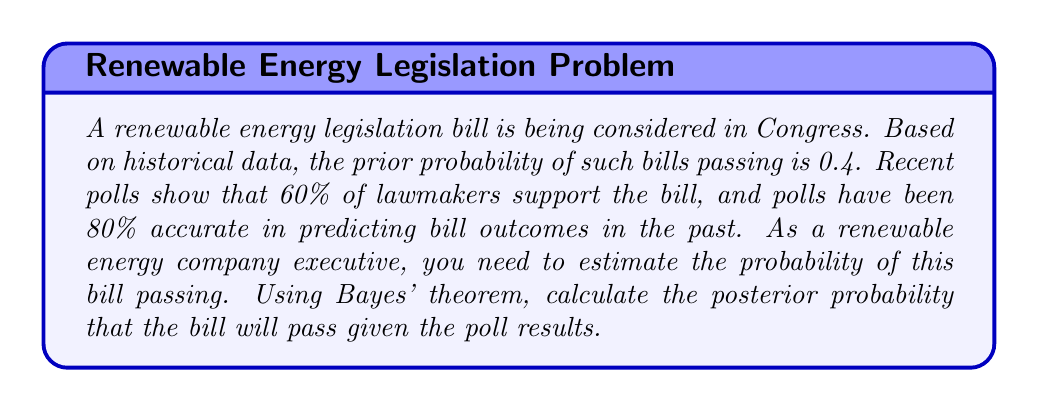Solve this math problem. Let's approach this step-by-step using Bayes' theorem:

1) Define our events:
   A: The bill passes
   B: The poll predicts the bill will pass

2) Given information:
   P(A) = 0.4 (prior probability of the bill passing)
   P(B|A) = 0.8 (probability of a correct poll prediction given the bill passes)
   P(B|not A) = 0.2 (probability of an incorrect poll prediction given the bill doesn't pass)
   P(B) = 0.6 (60% of lawmakers support the bill)

3) Bayes' theorem states:

   $$P(A|B) = \frac{P(B|A) \cdot P(A)}{P(B)}$$

4) We need to calculate P(B) using the law of total probability:

   $$P(B) = P(B|A) \cdot P(A) + P(B|not A) \cdot P(not A)$$
   $$P(B) = 0.8 \cdot 0.4 + 0.2 \cdot 0.6 = 0.32 + 0.12 = 0.44$$

5) Now we can apply Bayes' theorem:

   $$P(A|B) = \frac{0.8 \cdot 0.4}{0.44} = \frac{0.32}{0.44} \approx 0.7273$$

6) Convert to a percentage:
   0.7273 * 100 ≈ 72.73%
Answer: The posterior probability that the renewable energy legislation bill will pass, given the poll results, is approximately 72.73%. 